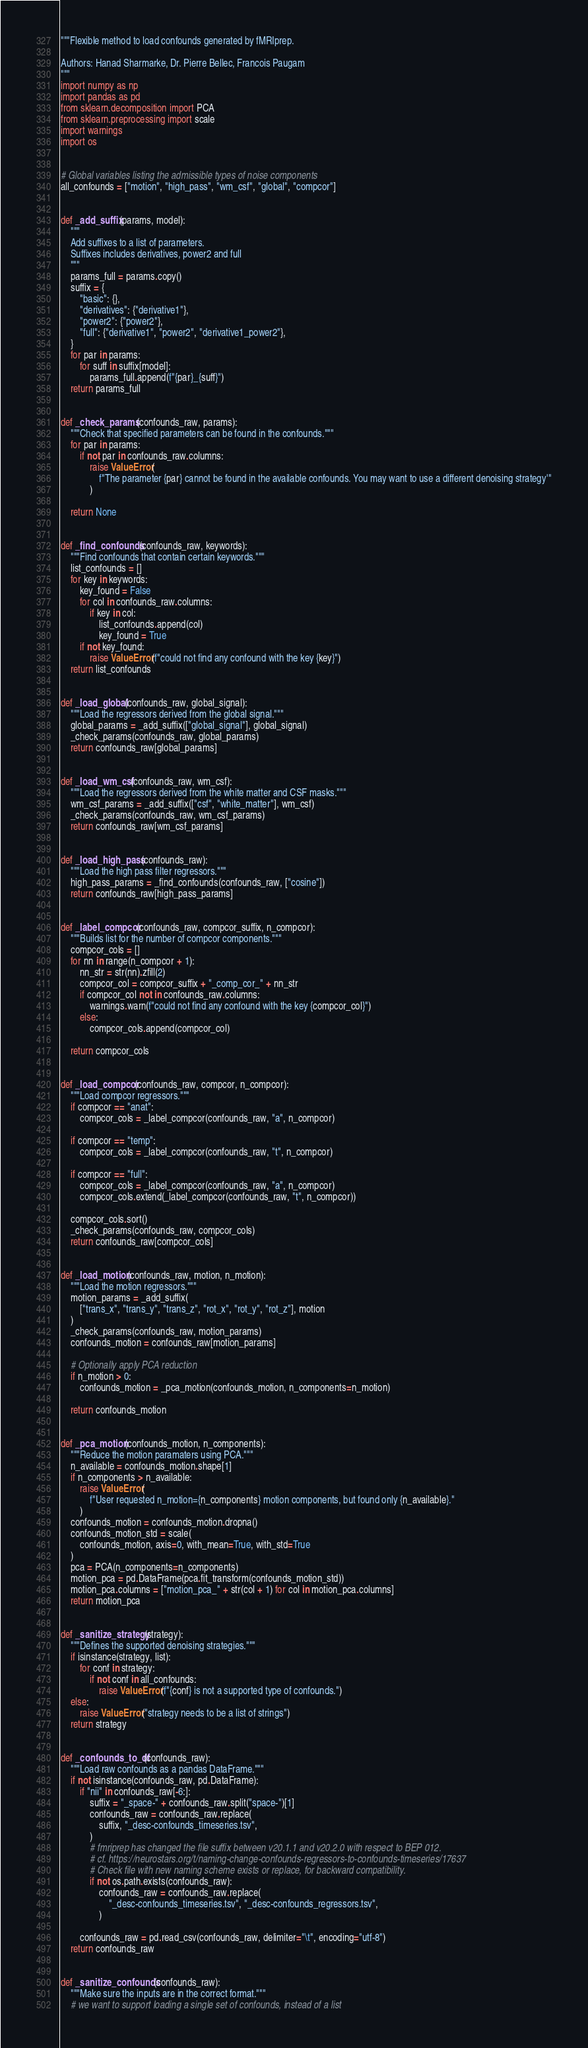<code> <loc_0><loc_0><loc_500><loc_500><_Python_>"""Flexible method to load confounds generated by fMRIprep.

Authors: Hanad Sharmarke, Dr. Pierre Bellec, Francois Paugam
"""
import numpy as np
import pandas as pd
from sklearn.decomposition import PCA
from sklearn.preprocessing import scale
import warnings
import os


# Global variables listing the admissible types of noise components
all_confounds = ["motion", "high_pass", "wm_csf", "global", "compcor"]


def _add_suffix(params, model):
    """
    Add suffixes to a list of parameters.
    Suffixes includes derivatives, power2 and full
    """
    params_full = params.copy()
    suffix = {
        "basic": {},
        "derivatives": {"derivative1"},
        "power2": {"power2"},
        "full": {"derivative1", "power2", "derivative1_power2"},
    }
    for par in params:
        for suff in suffix[model]:
            params_full.append(f"{par}_{suff}")
    return params_full


def _check_params(confounds_raw, params):
    """Check that specified parameters can be found in the confounds."""
    for par in params:
        if not par in confounds_raw.columns:
            raise ValueError(
                f"The parameter {par} cannot be found in the available confounds. You may want to use a different denoising strategy'"
            )

    return None


def _find_confounds(confounds_raw, keywords):
    """Find confounds that contain certain keywords."""
    list_confounds = []
    for key in keywords:
        key_found = False
        for col in confounds_raw.columns:
            if key in col:
                list_confounds.append(col)
                key_found = True
        if not key_found:
            raise ValueError(f"could not find any confound with the key {key}")
    return list_confounds


def _load_global(confounds_raw, global_signal):
    """Load the regressors derived from the global signal."""
    global_params = _add_suffix(["global_signal"], global_signal)
    _check_params(confounds_raw, global_params)
    return confounds_raw[global_params]


def _load_wm_csf(confounds_raw, wm_csf):
    """Load the regressors derived from the white matter and CSF masks."""
    wm_csf_params = _add_suffix(["csf", "white_matter"], wm_csf)
    _check_params(confounds_raw, wm_csf_params)
    return confounds_raw[wm_csf_params]


def _load_high_pass(confounds_raw):
    """Load the high pass filter regressors."""
    high_pass_params = _find_confounds(confounds_raw, ["cosine"])
    return confounds_raw[high_pass_params]


def _label_compcor(confounds_raw, compcor_suffix, n_compcor):
    """Builds list for the number of compcor components."""
    compcor_cols = []
    for nn in range(n_compcor + 1):
        nn_str = str(nn).zfill(2)
        compcor_col = compcor_suffix + "_comp_cor_" + nn_str
        if compcor_col not in confounds_raw.columns:
            warnings.warn(f"could not find any confound with the key {compcor_col}")
        else:
            compcor_cols.append(compcor_col)

    return compcor_cols


def _load_compcor(confounds_raw, compcor, n_compcor):
    """Load compcor regressors."""
    if compcor == "anat":
        compcor_cols = _label_compcor(confounds_raw, "a", n_compcor)

    if compcor == "temp":
        compcor_cols = _label_compcor(confounds_raw, "t", n_compcor)

    if compcor == "full":
        compcor_cols = _label_compcor(confounds_raw, "a", n_compcor)
        compcor_cols.extend(_label_compcor(confounds_raw, "t", n_compcor))

    compcor_cols.sort()
    _check_params(confounds_raw, compcor_cols)
    return confounds_raw[compcor_cols]


def _load_motion(confounds_raw, motion, n_motion):
    """Load the motion regressors."""
    motion_params = _add_suffix(
        ["trans_x", "trans_y", "trans_z", "rot_x", "rot_y", "rot_z"], motion
    )
    _check_params(confounds_raw, motion_params)
    confounds_motion = confounds_raw[motion_params]

    # Optionally apply PCA reduction
    if n_motion > 0:
        confounds_motion = _pca_motion(confounds_motion, n_components=n_motion)

    return confounds_motion


def _pca_motion(confounds_motion, n_components):
    """Reduce the motion paramaters using PCA."""
    n_available = confounds_motion.shape[1]
    if n_components > n_available:
        raise ValueError(
            f"User requested n_motion={n_components} motion components, but found only {n_available}."
        )
    confounds_motion = confounds_motion.dropna()
    confounds_motion_std = scale(
        confounds_motion, axis=0, with_mean=True, with_std=True
    )
    pca = PCA(n_components=n_components)
    motion_pca = pd.DataFrame(pca.fit_transform(confounds_motion_std))
    motion_pca.columns = ["motion_pca_" + str(col + 1) for col in motion_pca.columns]
    return motion_pca


def _sanitize_strategy(strategy):
    """Defines the supported denoising strategies."""
    if isinstance(strategy, list):
        for conf in strategy:
            if not conf in all_confounds:
                raise ValueError(f"{conf} is not a supported type of confounds.")
    else:
        raise ValueError("strategy needs to be a list of strings")
    return strategy


def _confounds_to_df(confounds_raw):
    """Load raw confounds as a pandas DataFrame."""
    if not isinstance(confounds_raw, pd.DataFrame):
        if "nii" in confounds_raw[-6:]:
            suffix = "_space-" + confounds_raw.split("space-")[1]
            confounds_raw = confounds_raw.replace(
                suffix, "_desc-confounds_timeseries.tsv",
            )
            # fmriprep has changed the file suffix between v20.1.1 and v20.2.0 with respect to BEP 012.
            # cf. https://neurostars.org/t/naming-change-confounds-regressors-to-confounds-timeseries/17637
            # Check file with new naming scheme exists or replace, for backward compatibility.
            if not os.path.exists(confounds_raw):
                confounds_raw = confounds_raw.replace(
                    "_desc-confounds_timeseries.tsv", "_desc-confounds_regressors.tsv",
                )

        confounds_raw = pd.read_csv(confounds_raw, delimiter="\t", encoding="utf-8")
    return confounds_raw


def _sanitize_confounds(confounds_raw):
    """Make sure the inputs are in the correct format."""
    # we want to support loading a single set of confounds, instead of a list</code> 